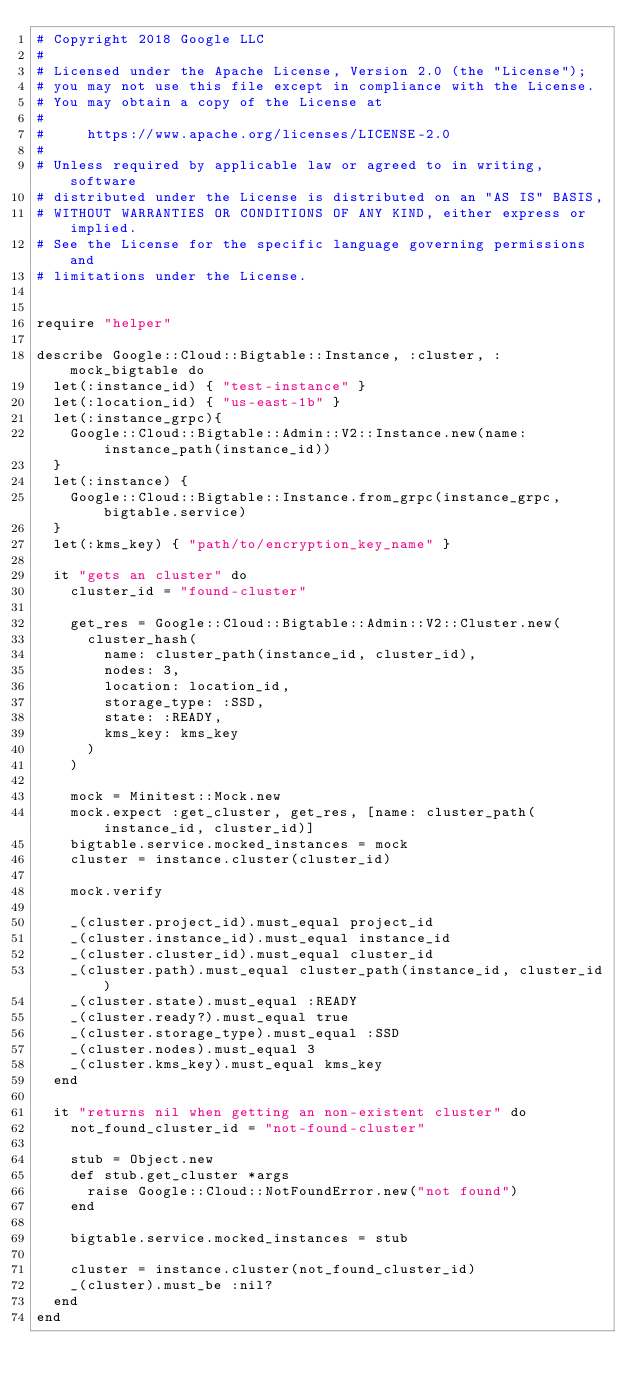Convert code to text. <code><loc_0><loc_0><loc_500><loc_500><_Ruby_># Copyright 2018 Google LLC
#
# Licensed under the Apache License, Version 2.0 (the "License");
# you may not use this file except in compliance with the License.
# You may obtain a copy of the License at
#
#     https://www.apache.org/licenses/LICENSE-2.0
#
# Unless required by applicable law or agreed to in writing, software
# distributed under the License is distributed on an "AS IS" BASIS,
# WITHOUT WARRANTIES OR CONDITIONS OF ANY KIND, either express or implied.
# See the License for the specific language governing permissions and
# limitations under the License.


require "helper"

describe Google::Cloud::Bigtable::Instance, :cluster, :mock_bigtable do
  let(:instance_id) { "test-instance" }
  let(:location_id) { "us-east-1b" }
  let(:instance_grpc){
    Google::Cloud::Bigtable::Admin::V2::Instance.new(name: instance_path(instance_id))
  }
  let(:instance) {
    Google::Cloud::Bigtable::Instance.from_grpc(instance_grpc, bigtable.service)
  }
  let(:kms_key) { "path/to/encryption_key_name" }

  it "gets an cluster" do
    cluster_id = "found-cluster"

    get_res = Google::Cloud::Bigtable::Admin::V2::Cluster.new(
      cluster_hash(
        name: cluster_path(instance_id, cluster_id),
        nodes: 3,
        location: location_id,
        storage_type: :SSD,
        state: :READY,
        kms_key: kms_key
      )
    )

    mock = Minitest::Mock.new
    mock.expect :get_cluster, get_res, [name: cluster_path(instance_id, cluster_id)]
    bigtable.service.mocked_instances = mock
    cluster = instance.cluster(cluster_id)

    mock.verify

    _(cluster.project_id).must_equal project_id
    _(cluster.instance_id).must_equal instance_id
    _(cluster.cluster_id).must_equal cluster_id
    _(cluster.path).must_equal cluster_path(instance_id, cluster_id)
    _(cluster.state).must_equal :READY
    _(cluster.ready?).must_equal true
    _(cluster.storage_type).must_equal :SSD
    _(cluster.nodes).must_equal 3
    _(cluster.kms_key).must_equal kms_key
  end

  it "returns nil when getting an non-existent cluster" do
    not_found_cluster_id = "not-found-cluster"

    stub = Object.new
    def stub.get_cluster *args
      raise Google::Cloud::NotFoundError.new("not found")
    end

    bigtable.service.mocked_instances = stub

    cluster = instance.cluster(not_found_cluster_id)
    _(cluster).must_be :nil?
  end
end
</code> 